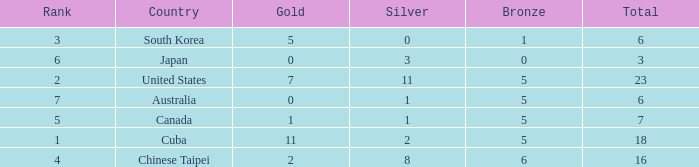What is the sum of the bronze medals when there were more than 2 silver medals and a rank larger than 6? None. 